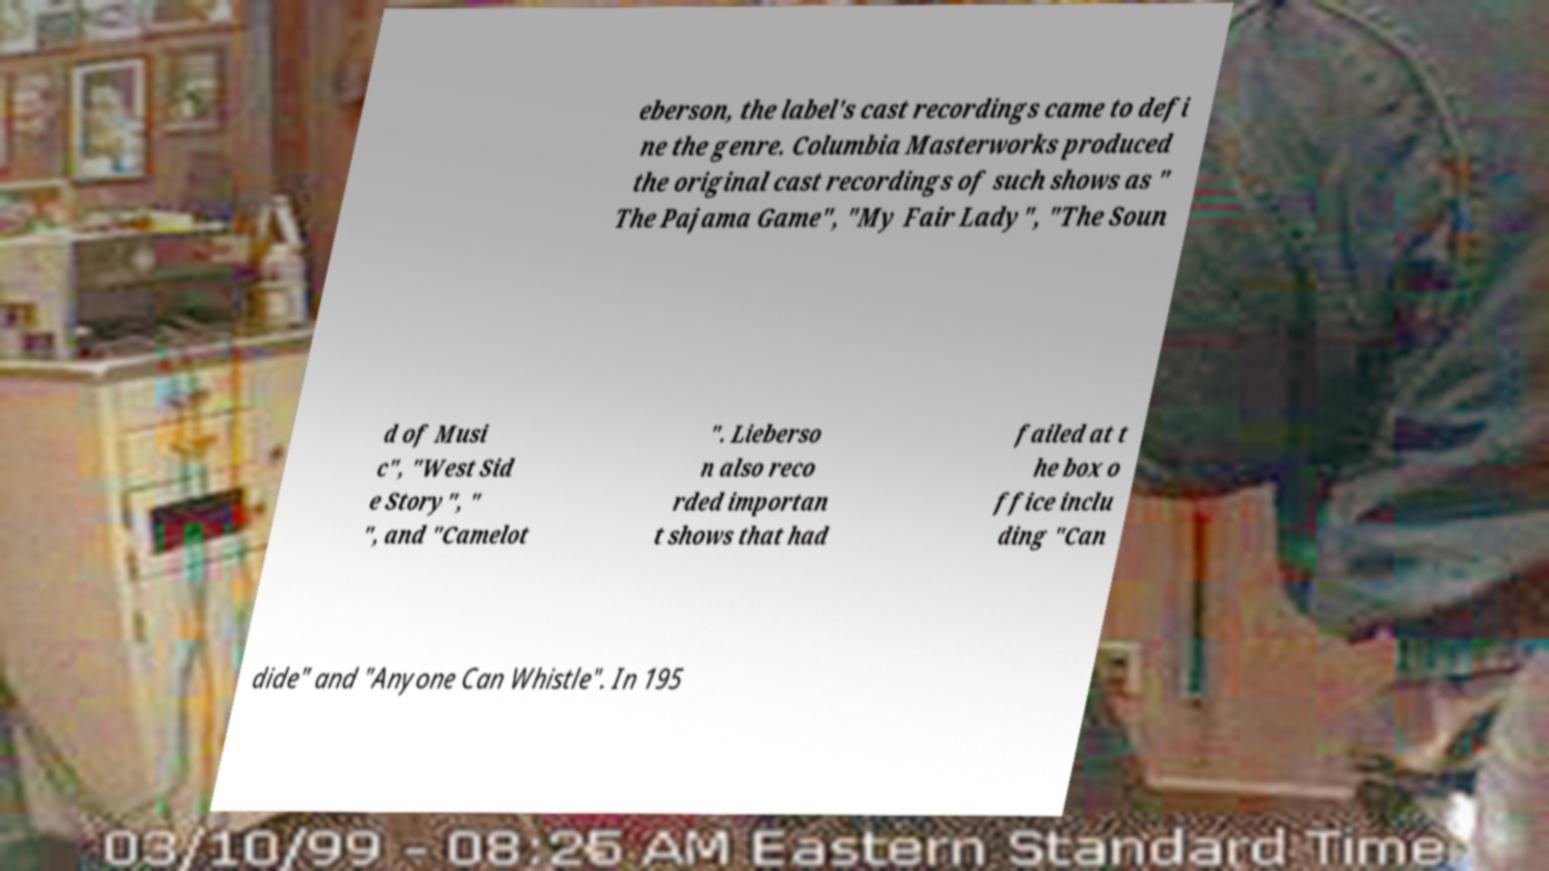Please identify and transcribe the text found in this image. eberson, the label's cast recordings came to defi ne the genre. Columbia Masterworks produced the original cast recordings of such shows as " The Pajama Game", "My Fair Lady", "The Soun d of Musi c", "West Sid e Story", " ", and "Camelot ". Lieberso n also reco rded importan t shows that had failed at t he box o ffice inclu ding "Can dide" and "Anyone Can Whistle". In 195 